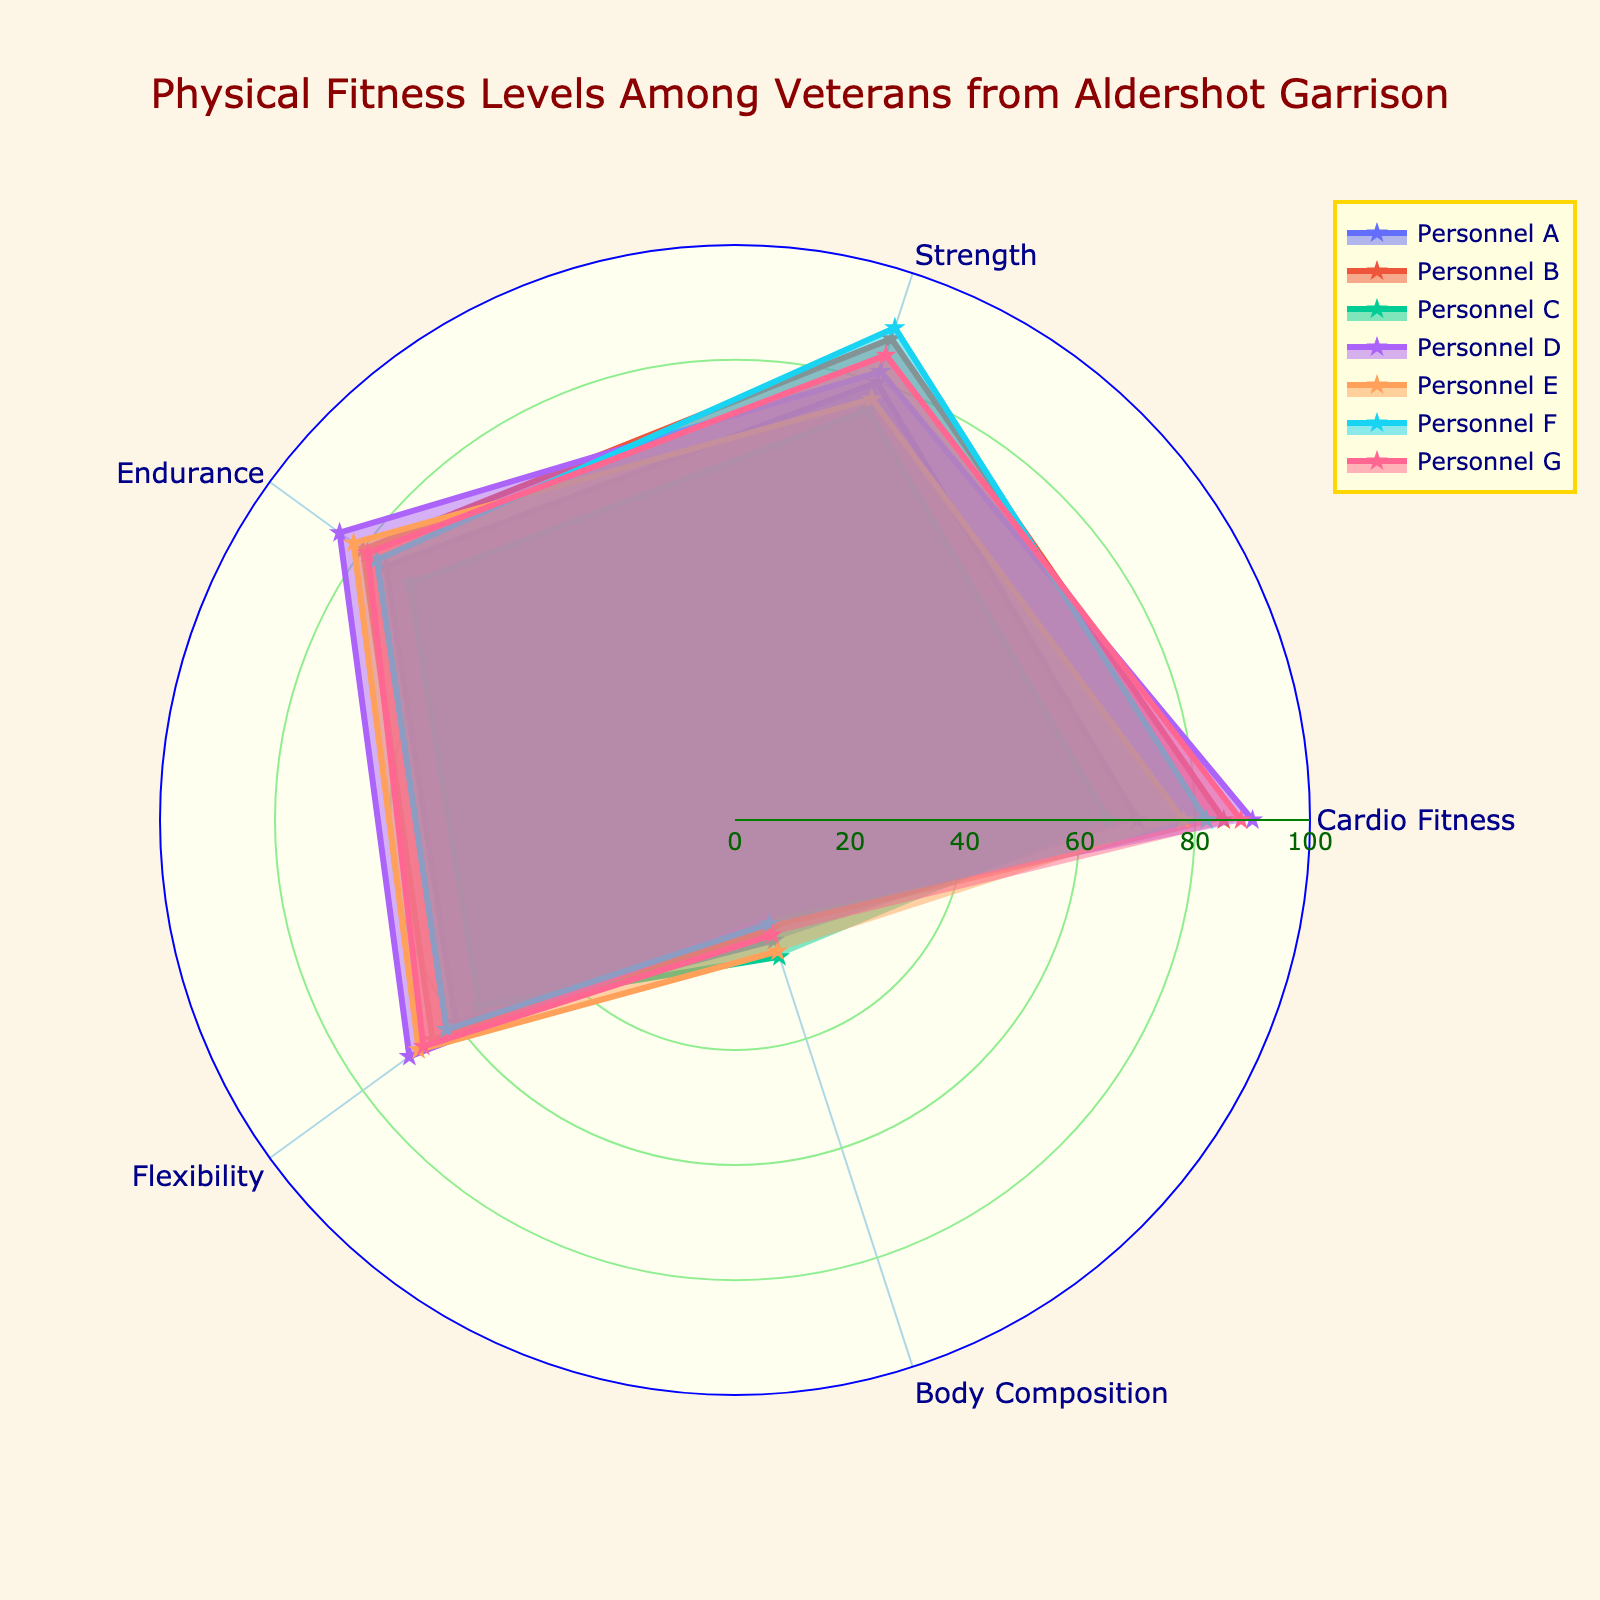what is the title of the chart? The title is prominently displayed at the top of the chart. It summarizes what the chart is about.
Answer: Physical Fitness Levels Among Veterans from Aldershot Garrison what are the categories represented in the polar chart? The categories encircle the chart and represent different aspects of physical fitness.
Answer: Cardio Fitness, Strength, Endurance, Flexibility, Body Composition Which personnel has the highest cardio fitness level? Among all plots, the highest value along the Cardio Fitness axis is associated with one personnel.
Answer: Personnel D What is the average strength level among all personnel? Sum the strength levels for all personnel and divide by the number of personnel to find the average: (80 + 88 + 75 + 82 + 77 + 90 + 85)/7
Answer: 81 Which personnel has the lowest body composition value? Examine the Body Composition axis and identify the lowest value across all personnel.
Answer: Personnel D Compare the cardio fitness level of Personnel A and Personnel G. Who has a higher level? Look at the cardio fitness values for Personnel A and Personnel G and compare them.
Answer: Personnel G How does flexibility compare between Personnel B and Personnel E? Compare the Flexibility values of Personnel B and Personnel E directly from the chart.
Answer: Personnel E has higher flexibility What is the combined strength and endurance level for Personnel F? Add the strength and endurance values for Personnel F: 90 (strength) + 77 (endurance).
Answer: 167 Which personnel has the most consistent fitness levels across all categories? The personnel with the least variation (i.e., the one whose line plot is more circular and balanced) has the most consistent levels.
Answer: Personnel G Who has the highest endurance level and what is the value? Identify the highest endurance value and the associated personnel.
Answer: Personnel D with a value of 85 